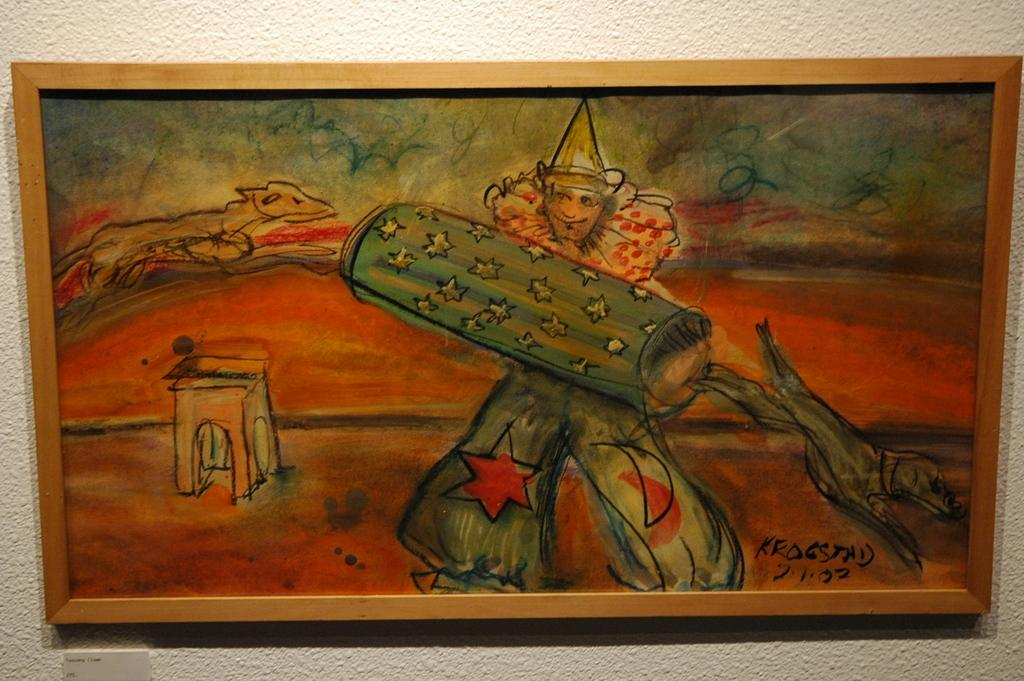What is depicted in the image? There is a painting in the image. Where is the painting located? The painting is on a wall. What is the subject of the painting? The painting features a joker. What is the joker doing in the painting? The joker is holding something in the painting. What type of beef is being served in the painting? There is no beef present in the image, as it features a painting of a joker holding something. 